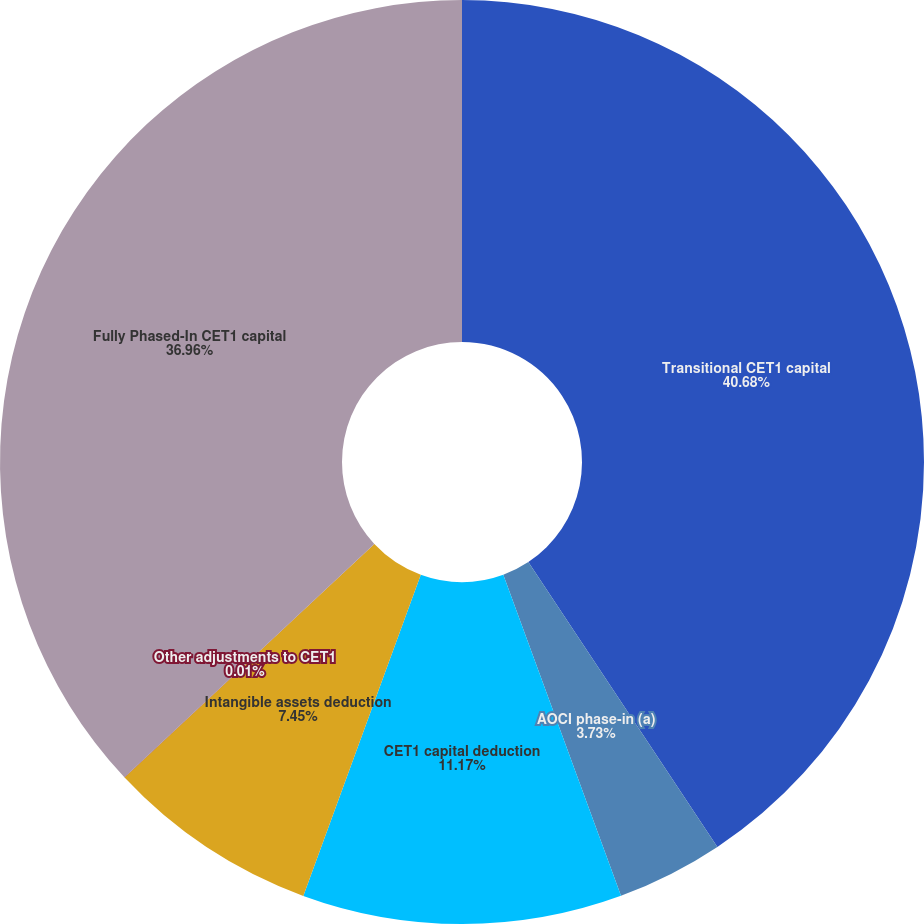Convert chart. <chart><loc_0><loc_0><loc_500><loc_500><pie_chart><fcel>Transitional CET1 capital<fcel>AOCI phase-in (a)<fcel>CET1 capital deduction<fcel>Intangible assets deduction<fcel>Other adjustments to CET1<fcel>Fully Phased-In CET1 capital<nl><fcel>40.67%<fcel>3.73%<fcel>11.17%<fcel>7.45%<fcel>0.01%<fcel>36.95%<nl></chart> 